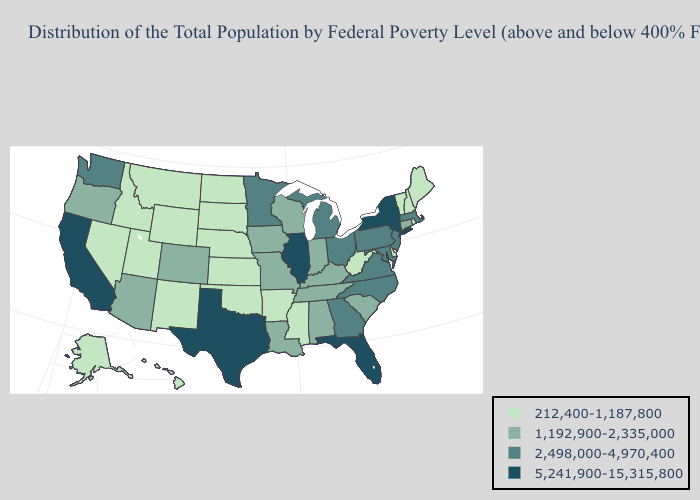What is the value of South Dakota?
Be succinct. 212,400-1,187,800. Name the states that have a value in the range 5,241,900-15,315,800?
Be succinct. California, Florida, Illinois, New York, Texas. Does the first symbol in the legend represent the smallest category?
Answer briefly. Yes. Name the states that have a value in the range 5,241,900-15,315,800?
Be succinct. California, Florida, Illinois, New York, Texas. Which states have the lowest value in the USA?
Write a very short answer. Alaska, Arkansas, Delaware, Hawaii, Idaho, Kansas, Maine, Mississippi, Montana, Nebraska, Nevada, New Hampshire, New Mexico, North Dakota, Oklahoma, Rhode Island, South Dakota, Utah, Vermont, West Virginia, Wyoming. Name the states that have a value in the range 212,400-1,187,800?
Give a very brief answer. Alaska, Arkansas, Delaware, Hawaii, Idaho, Kansas, Maine, Mississippi, Montana, Nebraska, Nevada, New Hampshire, New Mexico, North Dakota, Oklahoma, Rhode Island, South Dakota, Utah, Vermont, West Virginia, Wyoming. Among the states that border New Mexico , which have the lowest value?
Write a very short answer. Oklahoma, Utah. What is the value of Alabama?
Concise answer only. 1,192,900-2,335,000. Name the states that have a value in the range 5,241,900-15,315,800?
Short answer required. California, Florida, Illinois, New York, Texas. What is the lowest value in states that border Massachusetts?
Keep it brief. 212,400-1,187,800. What is the value of Minnesota?
Give a very brief answer. 2,498,000-4,970,400. Does California have the lowest value in the West?
Concise answer only. No. Does New York have a lower value than Utah?
Answer briefly. No. Does Illinois have the lowest value in the USA?
Answer briefly. No. Does Delaware have the lowest value in the South?
Concise answer only. Yes. 